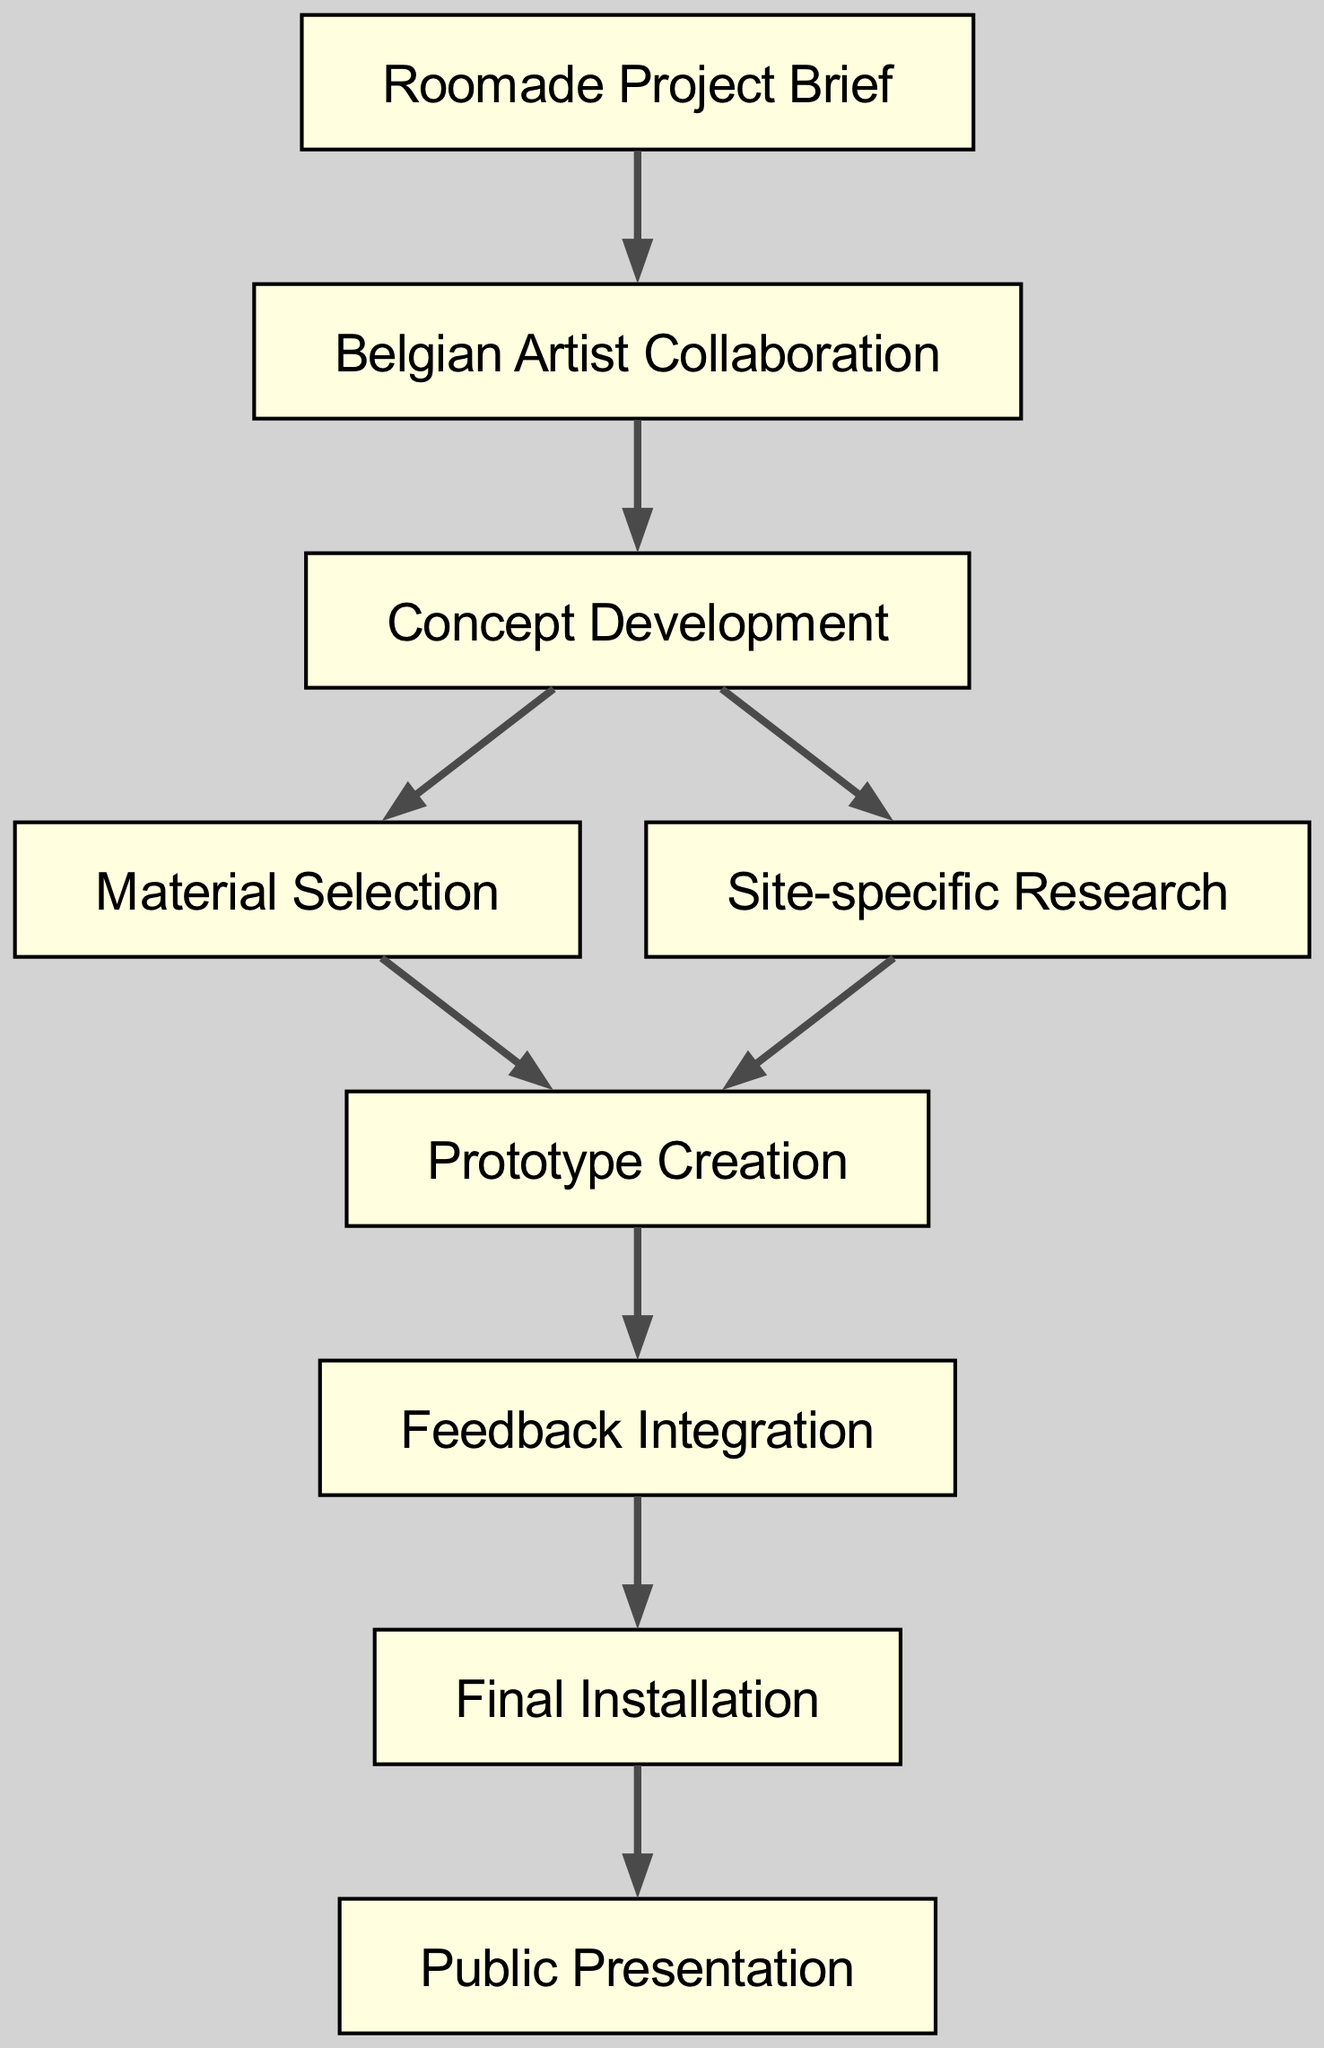What is the first step in the creative process? The first step identified in the diagram is "Roomade Project Brief." It is the starting point that leads to the next step of collaboration.
Answer: Roomade Project Brief How many nodes are present in the diagram? By counting the nodes listed in the data, we have a total of nine distinct nodes that represent different stages in the creative process.
Answer: 9 Which two nodes are linked directly? By examining the edges, one direct connection is between "Belgian Artist Collaboration" and "Concept Development," showing a relationship in the process flow.
Answer: Belgian Artist Collaboration and Concept Development What follows "Feedback Integration" in the process? The diagram shows that after "Feedback Integration," the next step is "Final Installation," indicating the progression of the project.
Answer: Final Installation Which node has the most connections? By reviewing the diagram, "Concept Development" has two outgoing edges: one leading to "Material Selection" and another to "Site-specific Research." This indicates it connects to multiple elements in the process.
Answer: Concept Development How many edges are present in the diagram? The edge count can be determined by counting the pairs listed under 'edges', resulting in a total of eight connections that represent the flow between nodes.
Answer: 8 What comes after "Material Selection"? The diagram specifies that after "Material Selection," the process moves to "Prototype Creation," showing the order of tasks involved.
Answer: Prototype Creation What is the final output of the entire process? The last node in the progression indicates that the final output of this creative process is "Public Presentation," showcasing the culmination of the installation efforts.
Answer: Public Presentation What type of research is done during the Concept Development phase? According to the diagram, there are two branches stemming from "Concept Development": one leading to "Material Selection" and another to "Site-specific Research," indicating a need to conduct research specific to the installation's location.
Answer: Site-specific Research 